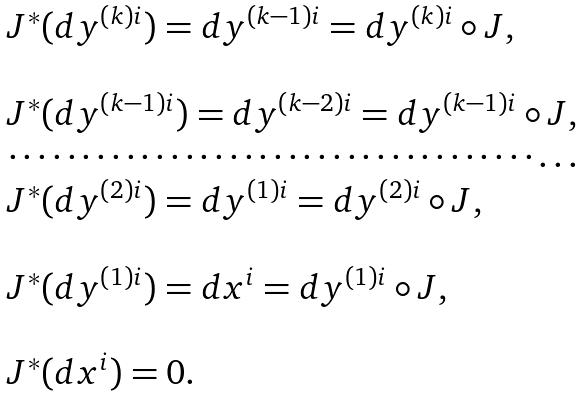<formula> <loc_0><loc_0><loc_500><loc_500>\begin{array} { l } J ^ { * } ( d y ^ { \left ( k \right ) i } ) = d y ^ { \left ( k - 1 \right ) i } = d y ^ { \left ( k \right ) i } \circ J , \\ \\ J ^ { * } ( d y ^ { \left ( k - 1 \right ) i } ) = d y ^ { \left ( k - 2 \right ) i } = d y ^ { \left ( k - 1 \right ) i } \circ J , \\ \cdots \cdots \cdots \cdots \cdots \cdots \cdots \cdots \cdots \cdots \cdots \cdots \dots \\ J ^ { * } ( d y ^ { \left ( 2 \right ) i } ) = d y ^ { \left ( 1 \right ) i } = d y ^ { \left ( 2 \right ) i } \circ J , \\ \\ J ^ { * } ( d y ^ { \left ( 1 \right ) i } ) = d x ^ { i } = d y ^ { \left ( 1 \right ) i } \circ J , \\ \\ J ^ { * } ( d x ^ { i } ) = 0 . \end{array}</formula> 